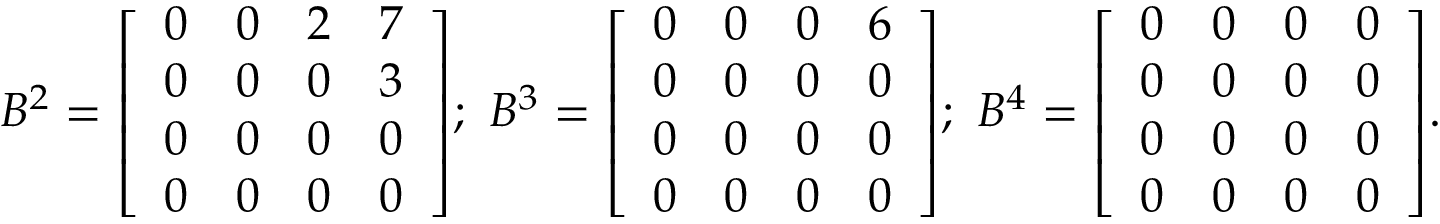Convert formula to latex. <formula><loc_0><loc_0><loc_500><loc_500>B ^ { 2 } = { \left [ \begin{array} { l l l l } { 0 } & { 0 } & { 2 } & { 7 } \\ { 0 } & { 0 } & { 0 } & { 3 } \\ { 0 } & { 0 } & { 0 } & { 0 } \\ { 0 } & { 0 } & { 0 } & { 0 } \end{array} \right ] } ; \ B ^ { 3 } = { \left [ \begin{array} { l l l l } { 0 } & { 0 } & { 0 } & { 6 } \\ { 0 } & { 0 } & { 0 } & { 0 } \\ { 0 } & { 0 } & { 0 } & { 0 } \\ { 0 } & { 0 } & { 0 } & { 0 } \end{array} \right ] } ; \ B ^ { 4 } = { \left [ \begin{array} { l l l l } { 0 } & { 0 } & { 0 } & { 0 } \\ { 0 } & { 0 } & { 0 } & { 0 } \\ { 0 } & { 0 } & { 0 } & { 0 } \\ { 0 } & { 0 } & { 0 } & { 0 } \end{array} \right ] } .</formula> 